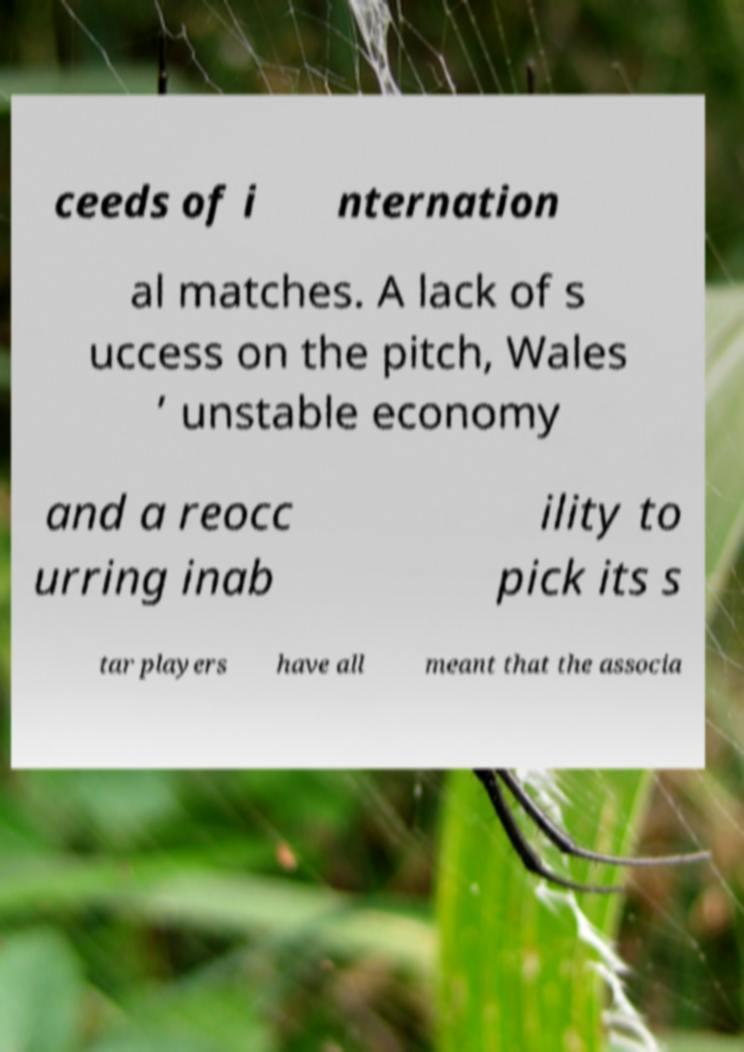What messages or text are displayed in this image? I need them in a readable, typed format. ceeds of i nternation al matches. A lack of s uccess on the pitch, Wales ’ unstable economy and a reocc urring inab ility to pick its s tar players have all meant that the associa 